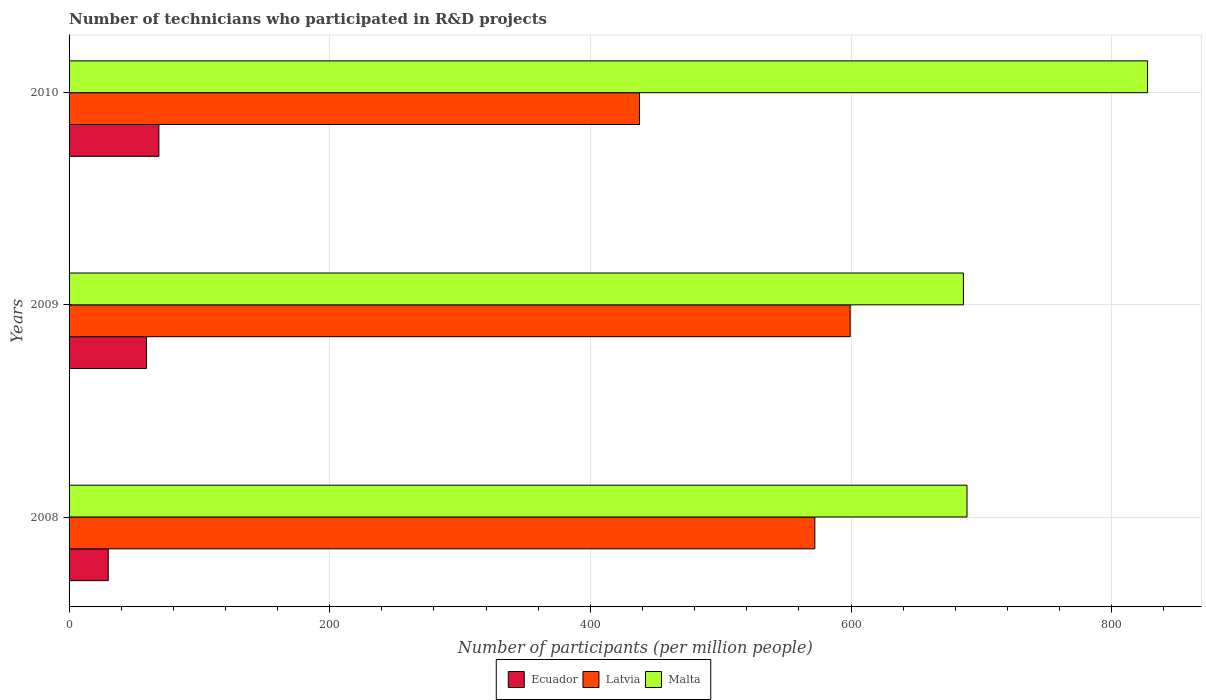How many different coloured bars are there?
Your response must be concise. 3. How many groups of bars are there?
Offer a very short reply. 3. How many bars are there on the 2nd tick from the bottom?
Make the answer very short. 3. What is the number of technicians who participated in R&D projects in Malta in 2008?
Provide a succinct answer. 688.99. Across all years, what is the maximum number of technicians who participated in R&D projects in Latvia?
Your answer should be compact. 599.35. Across all years, what is the minimum number of technicians who participated in R&D projects in Ecuador?
Provide a succinct answer. 30.05. In which year was the number of technicians who participated in R&D projects in Malta maximum?
Your response must be concise. 2010. What is the total number of technicians who participated in R&D projects in Malta in the graph?
Offer a very short reply. 2202.78. What is the difference between the number of technicians who participated in R&D projects in Latvia in 2009 and that in 2010?
Your answer should be compact. 161.66. What is the difference between the number of technicians who participated in R&D projects in Ecuador in 2010 and the number of technicians who participated in R&D projects in Latvia in 2008?
Give a very brief answer. -503.33. What is the average number of technicians who participated in R&D projects in Ecuador per year?
Offer a very short reply. 52.8. In the year 2010, what is the difference between the number of technicians who participated in R&D projects in Malta and number of technicians who participated in R&D projects in Latvia?
Provide a succinct answer. 389.85. What is the ratio of the number of technicians who participated in R&D projects in Ecuador in 2008 to that in 2010?
Give a very brief answer. 0.44. Is the number of technicians who participated in R&D projects in Ecuador in 2008 less than that in 2009?
Make the answer very short. Yes. Is the difference between the number of technicians who participated in R&D projects in Malta in 2008 and 2010 greater than the difference between the number of technicians who participated in R&D projects in Latvia in 2008 and 2010?
Offer a terse response. No. What is the difference between the highest and the second highest number of technicians who participated in R&D projects in Ecuador?
Make the answer very short. 9.47. What is the difference between the highest and the lowest number of technicians who participated in R&D projects in Latvia?
Your answer should be compact. 161.66. Is the sum of the number of technicians who participated in R&D projects in Latvia in 2008 and 2010 greater than the maximum number of technicians who participated in R&D projects in Ecuador across all years?
Give a very brief answer. Yes. What does the 3rd bar from the top in 2010 represents?
Your answer should be very brief. Ecuador. What does the 1st bar from the bottom in 2008 represents?
Make the answer very short. Ecuador. How many years are there in the graph?
Your answer should be compact. 3. What is the difference between two consecutive major ticks on the X-axis?
Your answer should be very brief. 200. Are the values on the major ticks of X-axis written in scientific E-notation?
Provide a short and direct response. No. Does the graph contain any zero values?
Offer a terse response. No. Where does the legend appear in the graph?
Your response must be concise. Bottom center. How many legend labels are there?
Ensure brevity in your answer.  3. How are the legend labels stacked?
Offer a terse response. Horizontal. What is the title of the graph?
Your answer should be very brief. Number of technicians who participated in R&D projects. What is the label or title of the X-axis?
Give a very brief answer. Number of participants (per million people). What is the label or title of the Y-axis?
Offer a terse response. Years. What is the Number of participants (per million people) of Ecuador in 2008?
Your answer should be compact. 30.05. What is the Number of participants (per million people) in Latvia in 2008?
Offer a very short reply. 572.24. What is the Number of participants (per million people) in Malta in 2008?
Give a very brief answer. 688.99. What is the Number of participants (per million people) of Ecuador in 2009?
Ensure brevity in your answer.  59.44. What is the Number of participants (per million people) in Latvia in 2009?
Ensure brevity in your answer.  599.35. What is the Number of participants (per million people) of Malta in 2009?
Offer a terse response. 686.24. What is the Number of participants (per million people) of Ecuador in 2010?
Provide a short and direct response. 68.91. What is the Number of participants (per million people) of Latvia in 2010?
Give a very brief answer. 437.69. What is the Number of participants (per million people) of Malta in 2010?
Make the answer very short. 827.54. Across all years, what is the maximum Number of participants (per million people) of Ecuador?
Ensure brevity in your answer.  68.91. Across all years, what is the maximum Number of participants (per million people) of Latvia?
Ensure brevity in your answer.  599.35. Across all years, what is the maximum Number of participants (per million people) in Malta?
Your response must be concise. 827.54. Across all years, what is the minimum Number of participants (per million people) in Ecuador?
Provide a succinct answer. 30.05. Across all years, what is the minimum Number of participants (per million people) in Latvia?
Provide a short and direct response. 437.69. Across all years, what is the minimum Number of participants (per million people) of Malta?
Ensure brevity in your answer.  686.24. What is the total Number of participants (per million people) in Ecuador in the graph?
Your response must be concise. 158.4. What is the total Number of participants (per million people) in Latvia in the graph?
Give a very brief answer. 1609.27. What is the total Number of participants (per million people) in Malta in the graph?
Offer a terse response. 2202.78. What is the difference between the Number of participants (per million people) in Ecuador in 2008 and that in 2009?
Offer a terse response. -29.38. What is the difference between the Number of participants (per million people) of Latvia in 2008 and that in 2009?
Your answer should be compact. -27.11. What is the difference between the Number of participants (per million people) in Malta in 2008 and that in 2009?
Your answer should be very brief. 2.75. What is the difference between the Number of participants (per million people) of Ecuador in 2008 and that in 2010?
Give a very brief answer. -38.85. What is the difference between the Number of participants (per million people) in Latvia in 2008 and that in 2010?
Provide a short and direct response. 134.55. What is the difference between the Number of participants (per million people) of Malta in 2008 and that in 2010?
Your answer should be very brief. -138.55. What is the difference between the Number of participants (per million people) in Ecuador in 2009 and that in 2010?
Your answer should be compact. -9.47. What is the difference between the Number of participants (per million people) in Latvia in 2009 and that in 2010?
Provide a short and direct response. 161.66. What is the difference between the Number of participants (per million people) of Malta in 2009 and that in 2010?
Your answer should be very brief. -141.3. What is the difference between the Number of participants (per million people) of Ecuador in 2008 and the Number of participants (per million people) of Latvia in 2009?
Give a very brief answer. -569.29. What is the difference between the Number of participants (per million people) in Ecuador in 2008 and the Number of participants (per million people) in Malta in 2009?
Your response must be concise. -656.19. What is the difference between the Number of participants (per million people) in Latvia in 2008 and the Number of participants (per million people) in Malta in 2009?
Provide a short and direct response. -114.01. What is the difference between the Number of participants (per million people) of Ecuador in 2008 and the Number of participants (per million people) of Latvia in 2010?
Provide a succinct answer. -407.64. What is the difference between the Number of participants (per million people) of Ecuador in 2008 and the Number of participants (per million people) of Malta in 2010?
Your response must be concise. -797.49. What is the difference between the Number of participants (per million people) in Latvia in 2008 and the Number of participants (per million people) in Malta in 2010?
Your response must be concise. -255.3. What is the difference between the Number of participants (per million people) in Ecuador in 2009 and the Number of participants (per million people) in Latvia in 2010?
Keep it short and to the point. -378.25. What is the difference between the Number of participants (per million people) in Ecuador in 2009 and the Number of participants (per million people) in Malta in 2010?
Provide a succinct answer. -768.1. What is the difference between the Number of participants (per million people) of Latvia in 2009 and the Number of participants (per million people) of Malta in 2010?
Provide a short and direct response. -228.2. What is the average Number of participants (per million people) in Ecuador per year?
Offer a terse response. 52.8. What is the average Number of participants (per million people) in Latvia per year?
Keep it short and to the point. 536.42. What is the average Number of participants (per million people) of Malta per year?
Provide a succinct answer. 734.26. In the year 2008, what is the difference between the Number of participants (per million people) of Ecuador and Number of participants (per million people) of Latvia?
Offer a terse response. -542.18. In the year 2008, what is the difference between the Number of participants (per million people) of Ecuador and Number of participants (per million people) of Malta?
Your answer should be very brief. -658.94. In the year 2008, what is the difference between the Number of participants (per million people) in Latvia and Number of participants (per million people) in Malta?
Provide a succinct answer. -116.75. In the year 2009, what is the difference between the Number of participants (per million people) in Ecuador and Number of participants (per million people) in Latvia?
Your answer should be very brief. -539.91. In the year 2009, what is the difference between the Number of participants (per million people) in Ecuador and Number of participants (per million people) in Malta?
Ensure brevity in your answer.  -626.81. In the year 2009, what is the difference between the Number of participants (per million people) in Latvia and Number of participants (per million people) in Malta?
Keep it short and to the point. -86.9. In the year 2010, what is the difference between the Number of participants (per million people) of Ecuador and Number of participants (per million people) of Latvia?
Keep it short and to the point. -368.78. In the year 2010, what is the difference between the Number of participants (per million people) in Ecuador and Number of participants (per million people) in Malta?
Keep it short and to the point. -758.63. In the year 2010, what is the difference between the Number of participants (per million people) of Latvia and Number of participants (per million people) of Malta?
Provide a short and direct response. -389.85. What is the ratio of the Number of participants (per million people) in Ecuador in 2008 to that in 2009?
Give a very brief answer. 0.51. What is the ratio of the Number of participants (per million people) of Latvia in 2008 to that in 2009?
Offer a terse response. 0.95. What is the ratio of the Number of participants (per million people) in Ecuador in 2008 to that in 2010?
Your answer should be compact. 0.44. What is the ratio of the Number of participants (per million people) of Latvia in 2008 to that in 2010?
Ensure brevity in your answer.  1.31. What is the ratio of the Number of participants (per million people) in Malta in 2008 to that in 2010?
Make the answer very short. 0.83. What is the ratio of the Number of participants (per million people) of Ecuador in 2009 to that in 2010?
Ensure brevity in your answer.  0.86. What is the ratio of the Number of participants (per million people) of Latvia in 2009 to that in 2010?
Your answer should be very brief. 1.37. What is the ratio of the Number of participants (per million people) in Malta in 2009 to that in 2010?
Ensure brevity in your answer.  0.83. What is the difference between the highest and the second highest Number of participants (per million people) in Ecuador?
Provide a succinct answer. 9.47. What is the difference between the highest and the second highest Number of participants (per million people) of Latvia?
Offer a very short reply. 27.11. What is the difference between the highest and the second highest Number of participants (per million people) in Malta?
Make the answer very short. 138.55. What is the difference between the highest and the lowest Number of participants (per million people) of Ecuador?
Give a very brief answer. 38.85. What is the difference between the highest and the lowest Number of participants (per million people) in Latvia?
Provide a succinct answer. 161.66. What is the difference between the highest and the lowest Number of participants (per million people) in Malta?
Your answer should be compact. 141.3. 